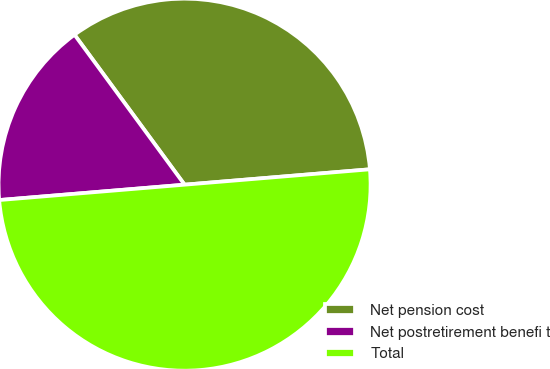Convert chart to OTSL. <chart><loc_0><loc_0><loc_500><loc_500><pie_chart><fcel>Net pension cost<fcel>Net postretirement benefi t<fcel>Total<nl><fcel>33.76%<fcel>16.24%<fcel>50.0%<nl></chart> 